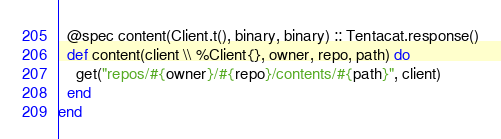<code> <loc_0><loc_0><loc_500><loc_500><_Elixir_>  @spec content(Client.t(), binary, binary) :: Tentacat.response()
  def content(client \\ %Client{}, owner, repo, path) do
    get("repos/#{owner}/#{repo}/contents/#{path}", client)
  end
end
</code> 